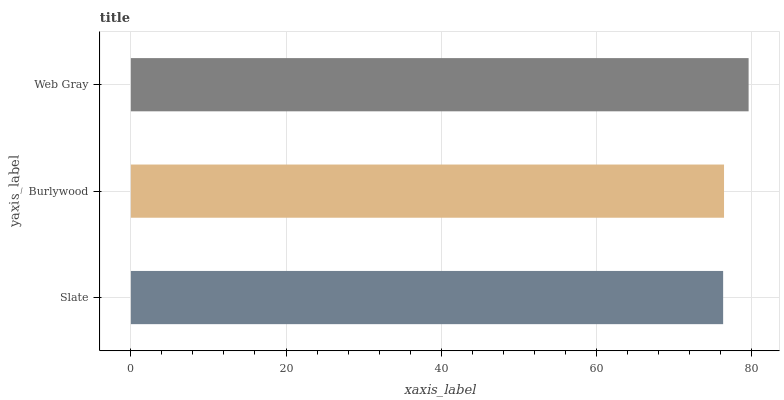Is Slate the minimum?
Answer yes or no. Yes. Is Web Gray the maximum?
Answer yes or no. Yes. Is Burlywood the minimum?
Answer yes or no. No. Is Burlywood the maximum?
Answer yes or no. No. Is Burlywood greater than Slate?
Answer yes or no. Yes. Is Slate less than Burlywood?
Answer yes or no. Yes. Is Slate greater than Burlywood?
Answer yes or no. No. Is Burlywood less than Slate?
Answer yes or no. No. Is Burlywood the high median?
Answer yes or no. Yes. Is Burlywood the low median?
Answer yes or no. Yes. Is Slate the high median?
Answer yes or no. No. Is Slate the low median?
Answer yes or no. No. 